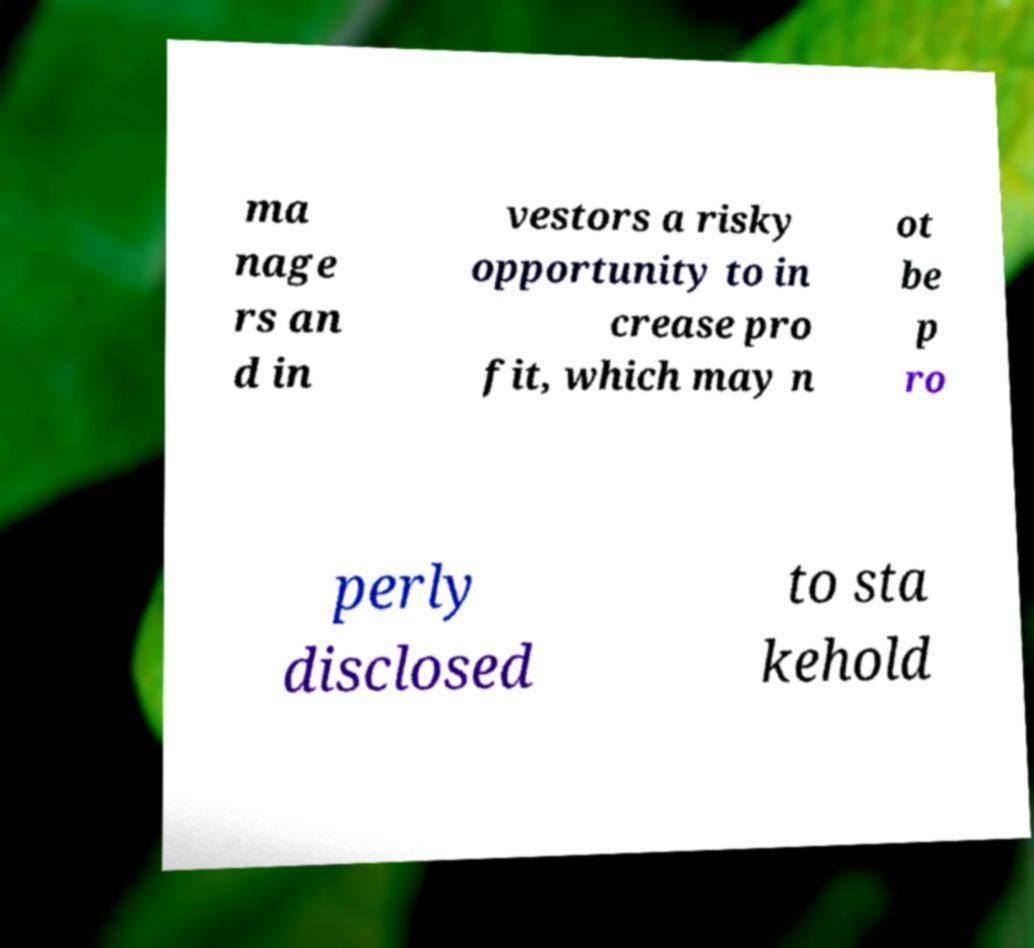What messages or text are displayed in this image? I need them in a readable, typed format. ma nage rs an d in vestors a risky opportunity to in crease pro fit, which may n ot be p ro perly disclosed to sta kehold 